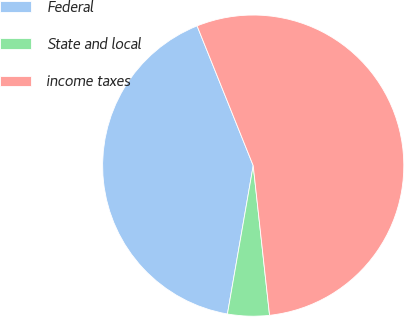Convert chart to OTSL. <chart><loc_0><loc_0><loc_500><loc_500><pie_chart><fcel>Federal<fcel>State and local<fcel>income taxes<nl><fcel>41.18%<fcel>4.47%<fcel>54.35%<nl></chart> 